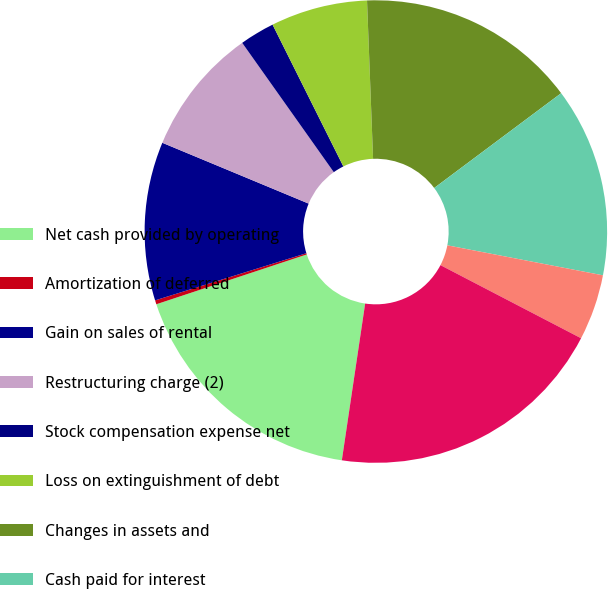Convert chart. <chart><loc_0><loc_0><loc_500><loc_500><pie_chart><fcel>Net cash provided by operating<fcel>Amortization of deferred<fcel>Gain on sales of rental<fcel>Restructuring charge (2)<fcel>Stock compensation expense net<fcel>Loss on extinguishment of debt<fcel>Changes in assets and<fcel>Cash paid for interest<fcel>Cash paid (received) for<fcel>EBITDA<nl><fcel>17.56%<fcel>0.28%<fcel>11.08%<fcel>8.92%<fcel>2.44%<fcel>6.76%<fcel>15.4%<fcel>13.24%<fcel>4.6%<fcel>19.72%<nl></chart> 